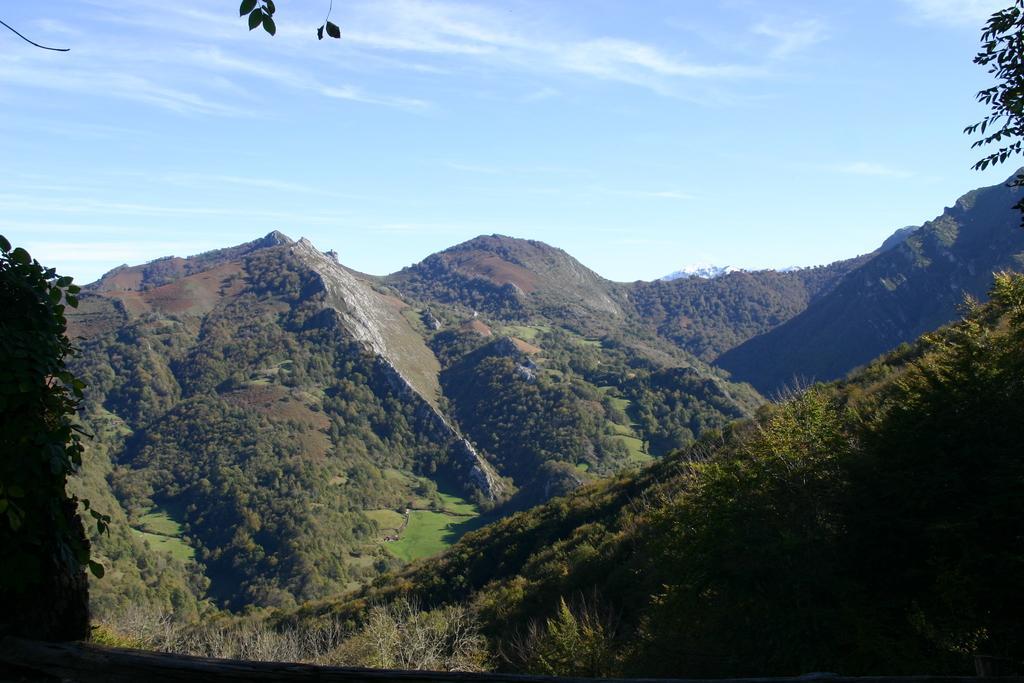Can you describe this image briefly? In this image, we can see hills and trees and at the top, there is sky. 